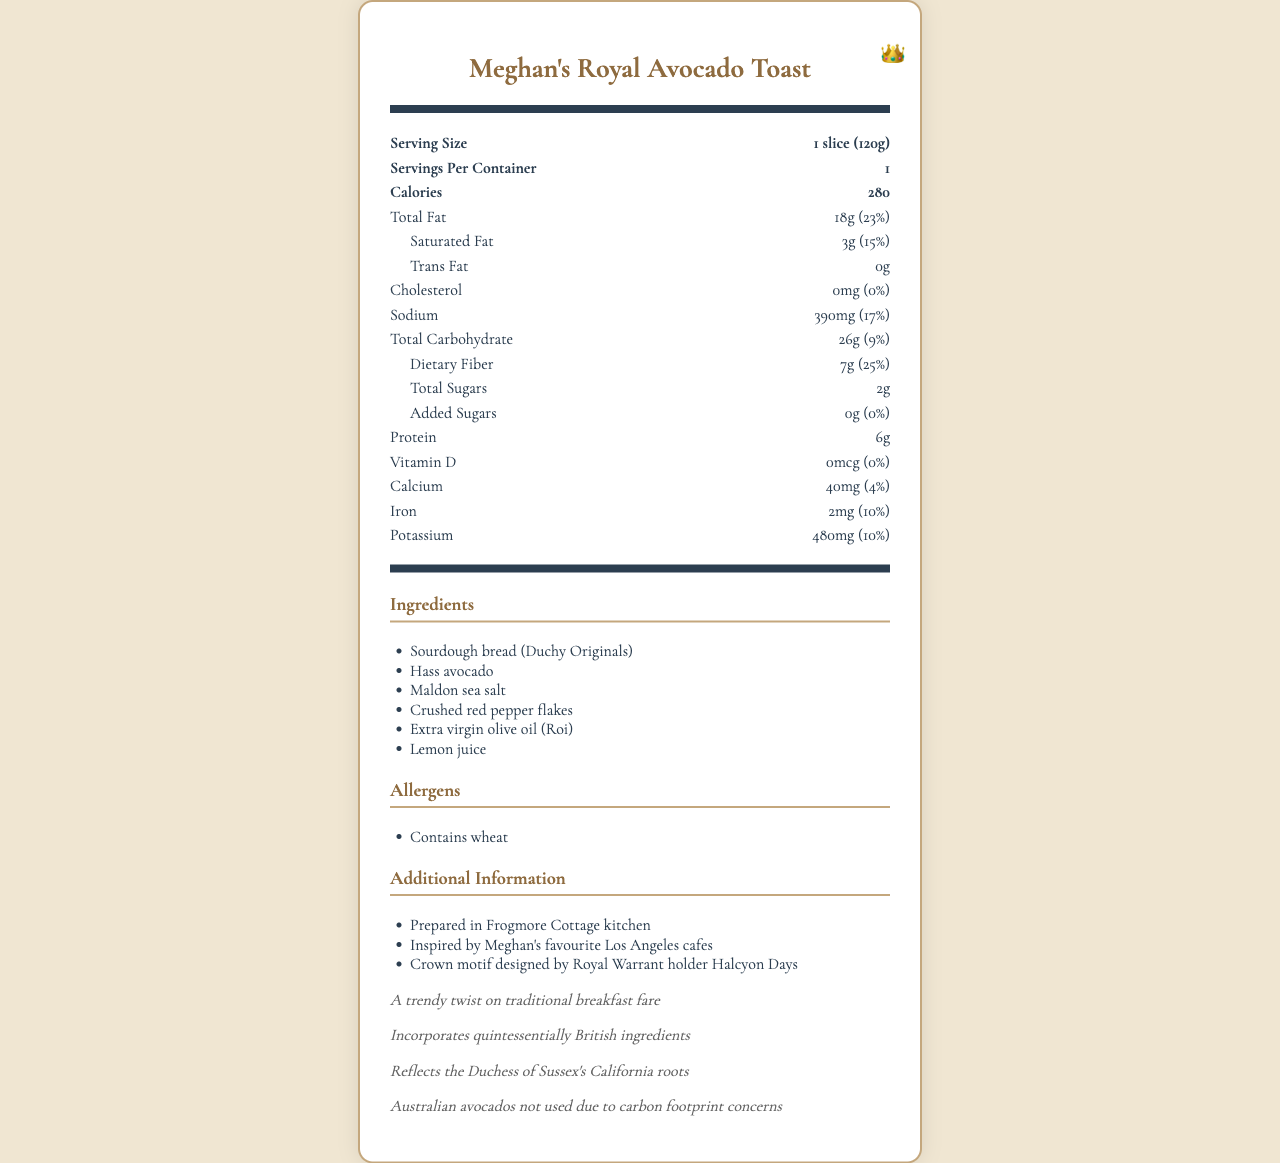How many calories are in one serving of Meghan's Royal Avocado Toast? The document specifies that each serving contains 280 calories.
Answer: 280 What is the serving size of Meghan's Royal Avocado Toast? The document states that the serving size is 1 slice (120g).
Answer: 1 slice (120g) What is the main ingredient in Meghan's Royal Avocado Toast? Sourdough bread (Duchy Originals) is listed as the first ingredient, indicating it is the main ingredient.
Answer: Sourdough bread (Duchy Originals) How much protein does one serving of Meghan's Royal Avocado Toast contain? The document specifies that one serving contains 6 grams of protein.
Answer: 6g What are the allergens listed for Meghan's Royal Avocado Toast? The document lists "Contains wheat" as the allergen information.
Answer: Contains wheat What is the percentage of the daily value of saturated fat in one serving? The document states that one serving has 15% of the daily value for saturated fat.
Answer: 15% Does Meghan's Royal Avocado Toast contain any cholesterol? The document specifies that it contains 0mg of cholesterol, which translates to 0% daily value.
Answer: No Which ingredient is not used in Meghan's Royal Avocado Toast for environmental reasons? A. Hass avocado B. Australian avocado C. Maldon sea salt D. Lemon juice The document mentions that Australian avocados are not used due to carbon footprint concerns.
Answer: B How much dietary fiber is in one serving of Meghan's Royal Avocado Toast? The document states that one serving contains 7 grams of dietary fiber.
Answer: 7g Which of the following additional information is included in the document about Meghan's Royal Avocado Toast? (Select all that apply) I. Prepared in Frogmore Cottage kitchen II. Inspired by Meghan's favorite Los Angeles cafes III. Crown motif designed by Gordon Ramsay The document states that the recipe is prepared in Frogmore Cottage kitchen and inspired by Meghan's favorite Los Angeles cafes. The crown motif is designed by Royal Warrant holder Halcyon Days, not Gordon Ramsay.
Answer: I and II Is Meghan's Royal Avocado Toast inspired by Meghan Markle's California roots? The document mentions that the toast reflects the Duchess of Sussex's California roots.
Answer: Yes Can you tell when the recipe was developed? The document does not provide any information about when the recipe was developed.
Answer: Not enough information Describe the entire document or the main idea of the document. This document provides detailed information about Meghan's Royal Avocado Toast, including its nutritional profile, ingredients, allergens, and some background information on its inspiration and special features.
Answer: Meghan's Royal Avocado Toast is a nutritious recipe featuring ingredients like sourdough bread, Hass avocado, Maldon sea salt, and lemon juice. It includes nutritional facts, such as calorie content, fat, cholesterol, sodium, carbohydrates, protein, and various vitamins and minerals. The document also lists allergens, additional information about the inspiration and origin of the recipe, a note on the crown motif design, and a brief mention of environmental concerns regarding Australian avocados. What is the total amount of sugars in one serving, including added sugars? The document specifies that total sugars amount to 2 grams and added sugars are 0 grams.
Answer: 2g From which country did they avoid sourcing avocados for Meghan's Royal Avocado Toast? The document mentions that Australian avocados were not used due to carbon footprint concerns.
Answer: Australia 